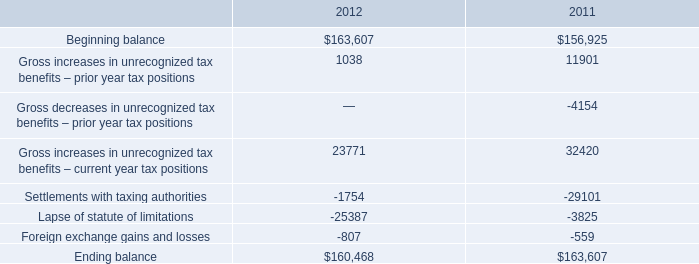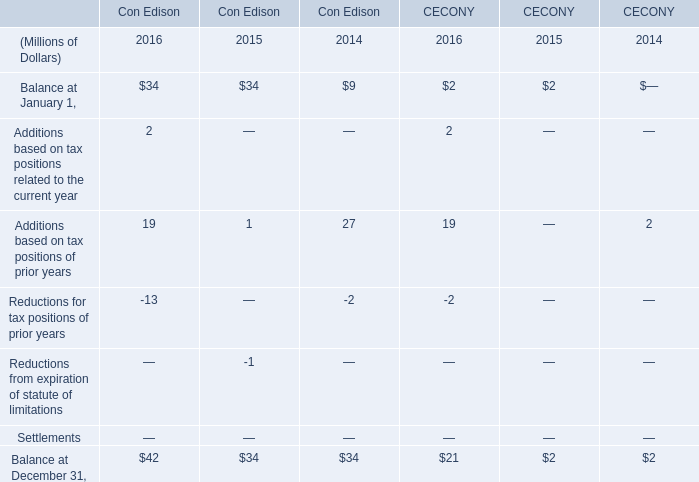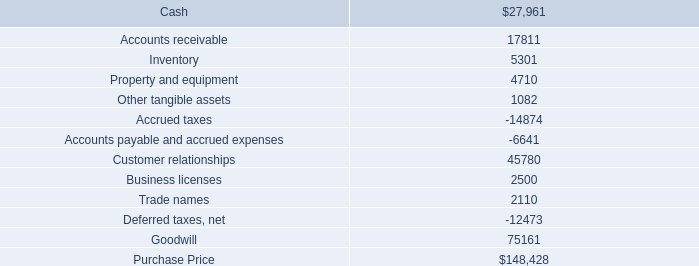what's the total amount of Beginning balance of 2011, and Accounts payable and accrued expenses ? 
Computations: (156925.0 + 6641.0)
Answer: 163566.0. what is the percentage change in total gross amount of unrecognized tax benefits from 2010 to 2011? 
Computations: ((163607 - 156925) / 156925)
Answer: 0.04258. 